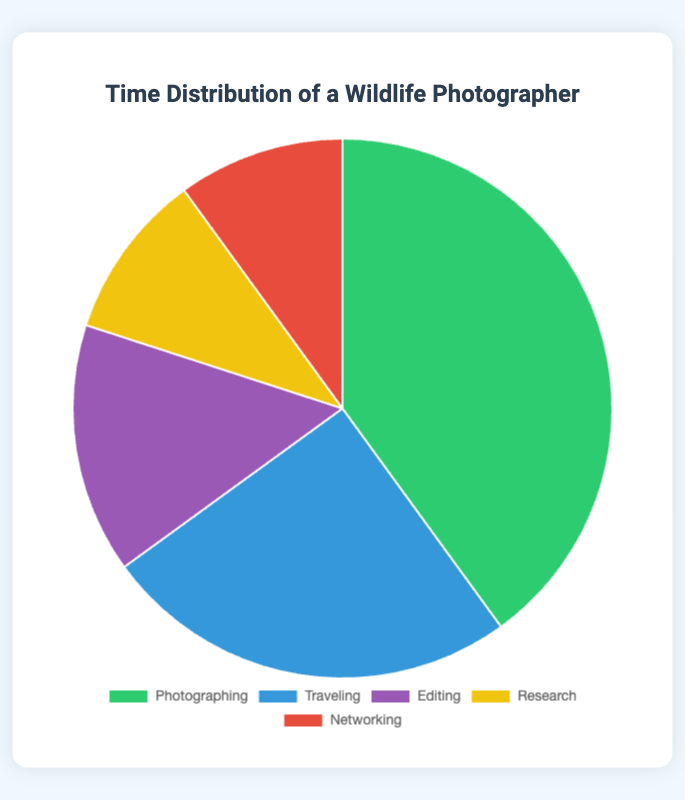Which activity consumes the highest percentage of time? The pie chart shows that the segment representing "Photographing" is the largest, occupying 40% of the total time.
Answer: Photographing How much more time is spent on Photographing than on Research? The time spent on Photographing is 40%, and the time spent on Research is 10%. Subtracting the two gives 40% - 10% = 30%.
Answer: 30% What is the total percentage of time spent on Editing and Networking combined? The time spent on Editing is 15%, and the time spent on Networking is 10%. Adding the two gives 15% + 10% = 25%.
Answer: 25% Which activities each consume 10% of the total time? The pie chart shows that "Research" and "Networking" each take up 10% of the total time.
Answer: Research and Networking What percentage of time is spent on Photographing and Traveling together? The time spent on Photographing is 40%, and the time spent on Traveling is 25%. Adding the two gives 40% + 25% = 65%.
Answer: 65% Is more time spent on Traveling or Editing? The pie chart shows that 25% of the time is spent on Traveling whereas 15% is spent on Editing. Therefore, more time is spent on Traveling.
Answer: Traveling What is the difference between the time spent on Traveling and the time spent on Networking? The time spent on Traveling is 25%, and the time spent on Networking is 10%. Subtracting the two gives 25% - 10% = 15%.
Answer: 15% Which color represents Research in the pie chart? By looking at the colors in the pie chart, we can see that the yellow segment corresponds to the "Research" activity.
Answer: Yellow What is the average percentage of time spent on Editing, Research, and Networking? The time spent on Editing, Research, and Networking are 15%, 10%, and 10% respectively. Adding these gives 15% + 10% + 10% = 35%. Dividing by 3 gives 35% / 3 ≈ 11.67%.
Answer: 11.67% If the time spent Traveling were reduced by 5%, what would be the new percentage and total for Traveling and Research combined? The current time spent Traveling is 25%. Reducing it by 5% gives 25% - 5% = 20%. Adding this to the time spent on Research, which is 10%, we get 20% + 10% = 30%.
Answer: 20%, 30% 